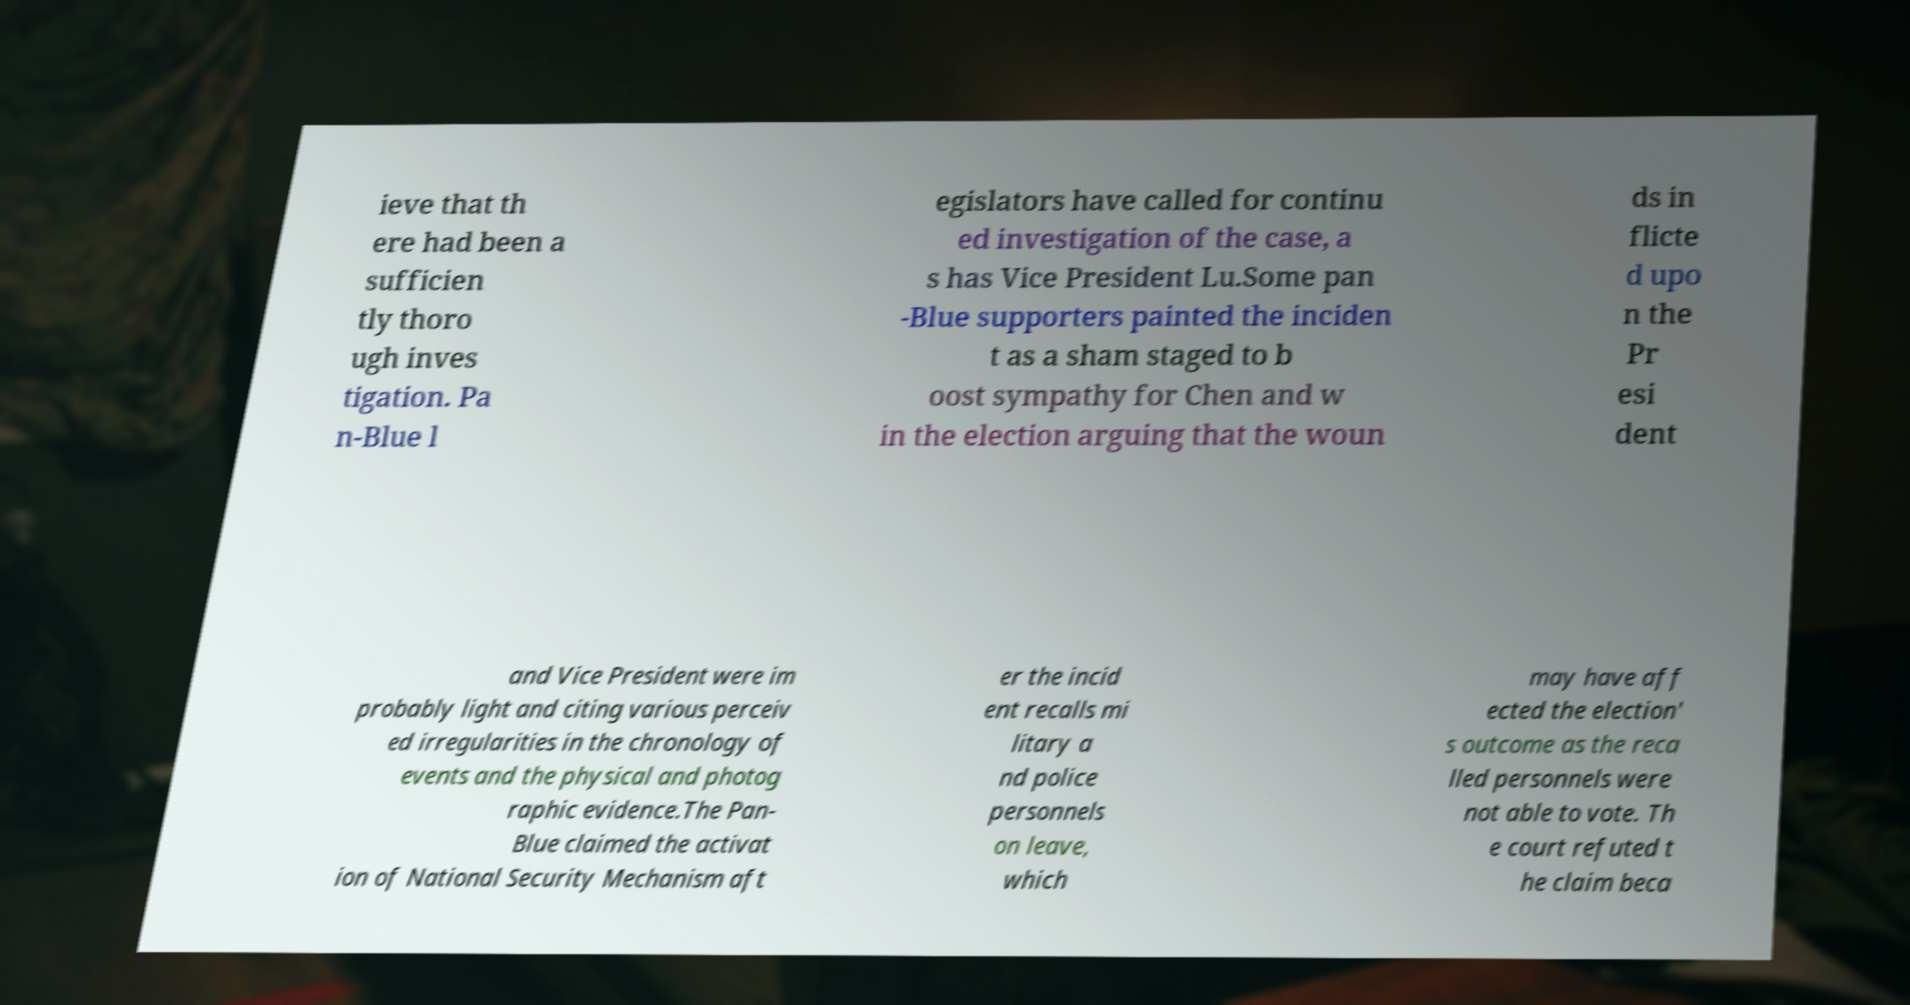Please identify and transcribe the text found in this image. ieve that th ere had been a sufficien tly thoro ugh inves tigation. Pa n-Blue l egislators have called for continu ed investigation of the case, a s has Vice President Lu.Some pan -Blue supporters painted the inciden t as a sham staged to b oost sympathy for Chen and w in the election arguing that the woun ds in flicte d upo n the Pr esi dent and Vice President were im probably light and citing various perceiv ed irregularities in the chronology of events and the physical and photog raphic evidence.The Pan- Blue claimed the activat ion of National Security Mechanism aft er the incid ent recalls mi litary a nd police personnels on leave, which may have aff ected the election' s outcome as the reca lled personnels were not able to vote. Th e court refuted t he claim beca 